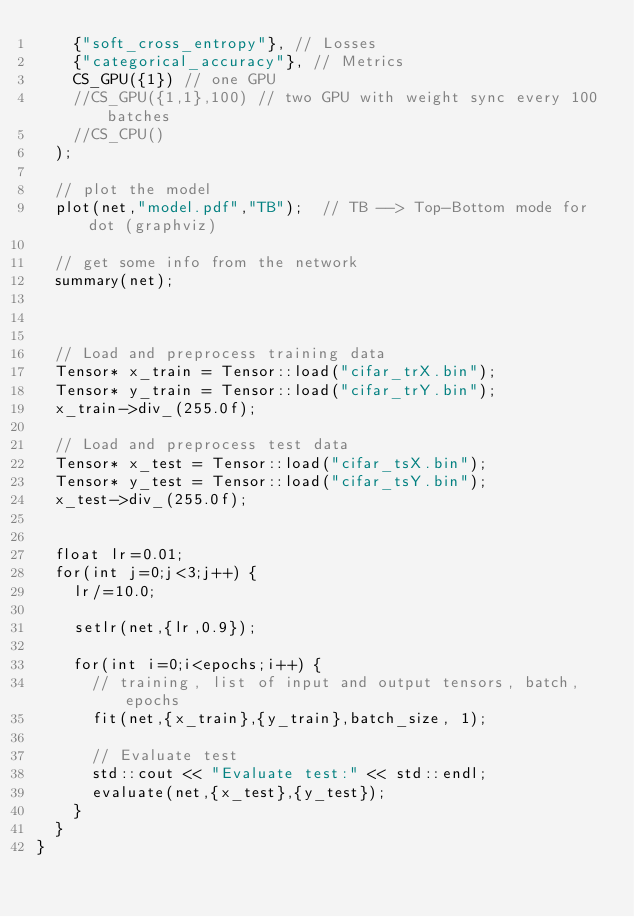Convert code to text. <code><loc_0><loc_0><loc_500><loc_500><_C++_>    {"soft_cross_entropy"}, // Losses
    {"categorical_accuracy"}, // Metrics
    CS_GPU({1}) // one GPU
    //CS_GPU({1,1},100) // two GPU with weight sync every 100 batches
    //CS_CPU()
  );

  // plot the model
  plot(net,"model.pdf","TB");  // TB --> Top-Bottom mode for dot (graphviz)

  // get some info from the network
  summary(net);



  // Load and preprocess training data
  Tensor* x_train = Tensor::load("cifar_trX.bin");
  Tensor* y_train = Tensor::load("cifar_trY.bin");
  x_train->div_(255.0f);

  // Load and preprocess test data
  Tensor* x_test = Tensor::load("cifar_tsX.bin");
  Tensor* y_test = Tensor::load("cifar_tsY.bin");
  x_test->div_(255.0f);


  float lr=0.01;
  for(int j=0;j<3;j++) {
    lr/=10.0;

    setlr(net,{lr,0.9});

    for(int i=0;i<epochs;i++) {
      // training, list of input and output tensors, batch, epochs
      fit(net,{x_train},{y_train},batch_size, 1);

      // Evaluate test
      std::cout << "Evaluate test:" << std::endl;
      evaluate(net,{x_test},{y_test});
    }
  }
}
</code> 